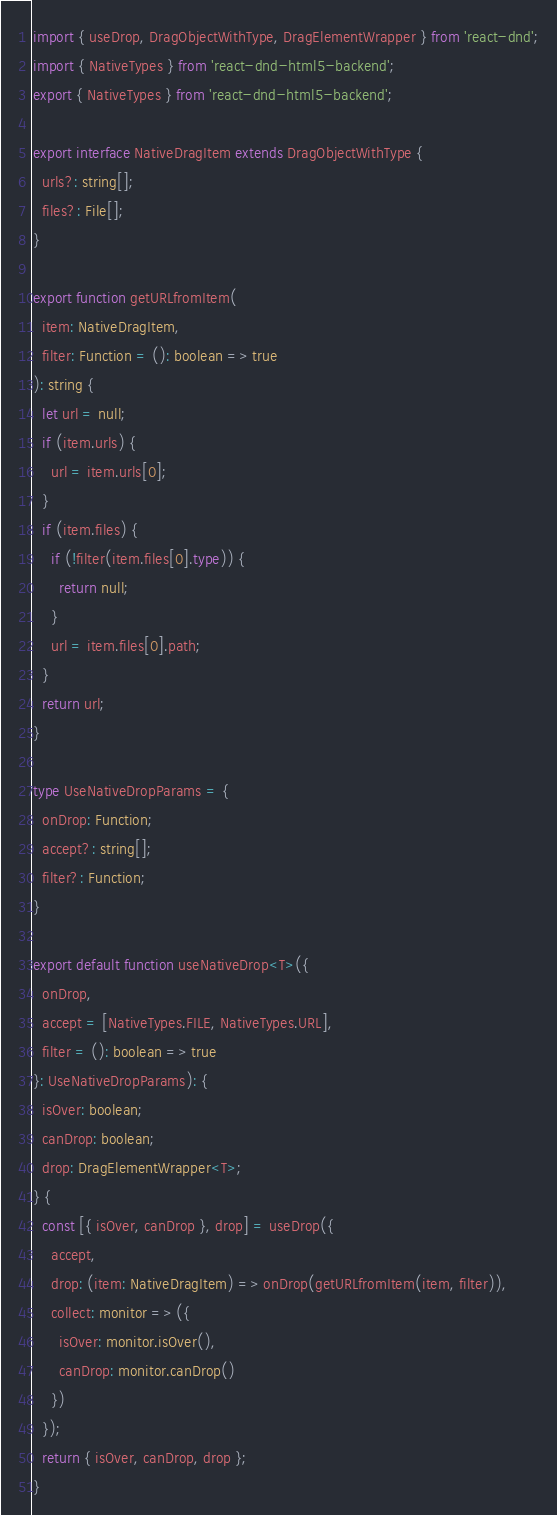Convert code to text. <code><loc_0><loc_0><loc_500><loc_500><_TypeScript_>import { useDrop, DragObjectWithType, DragElementWrapper } from 'react-dnd';
import { NativeTypes } from 'react-dnd-html5-backend';
export { NativeTypes } from 'react-dnd-html5-backend';

export interface NativeDragItem extends DragObjectWithType {
  urls?: string[];
  files?: File[];
}

export function getURLfromItem(
  item: NativeDragItem,
  filter: Function = (): boolean => true
): string {
  let url = null;
  if (item.urls) {
    url = item.urls[0];
  }
  if (item.files) {
    if (!filter(item.files[0].type)) {
      return null;
    }
    url = item.files[0].path;
  }
  return url;
}

type UseNativeDropParams = {
  onDrop: Function;
  accept?: string[];
  filter?: Function;
}

export default function useNativeDrop<T>({
  onDrop,
  accept = [NativeTypes.FILE, NativeTypes.URL],
  filter = (): boolean => true
}: UseNativeDropParams): {
  isOver: boolean;
  canDrop: boolean;
  drop: DragElementWrapper<T>;
} {
  const [{ isOver, canDrop }, drop] = useDrop({
    accept,
    drop: (item: NativeDragItem) => onDrop(getURLfromItem(item, filter)),
    collect: monitor => ({
      isOver: monitor.isOver(),
      canDrop: monitor.canDrop()
    })
  });
  return { isOver, canDrop, drop };
}
</code> 